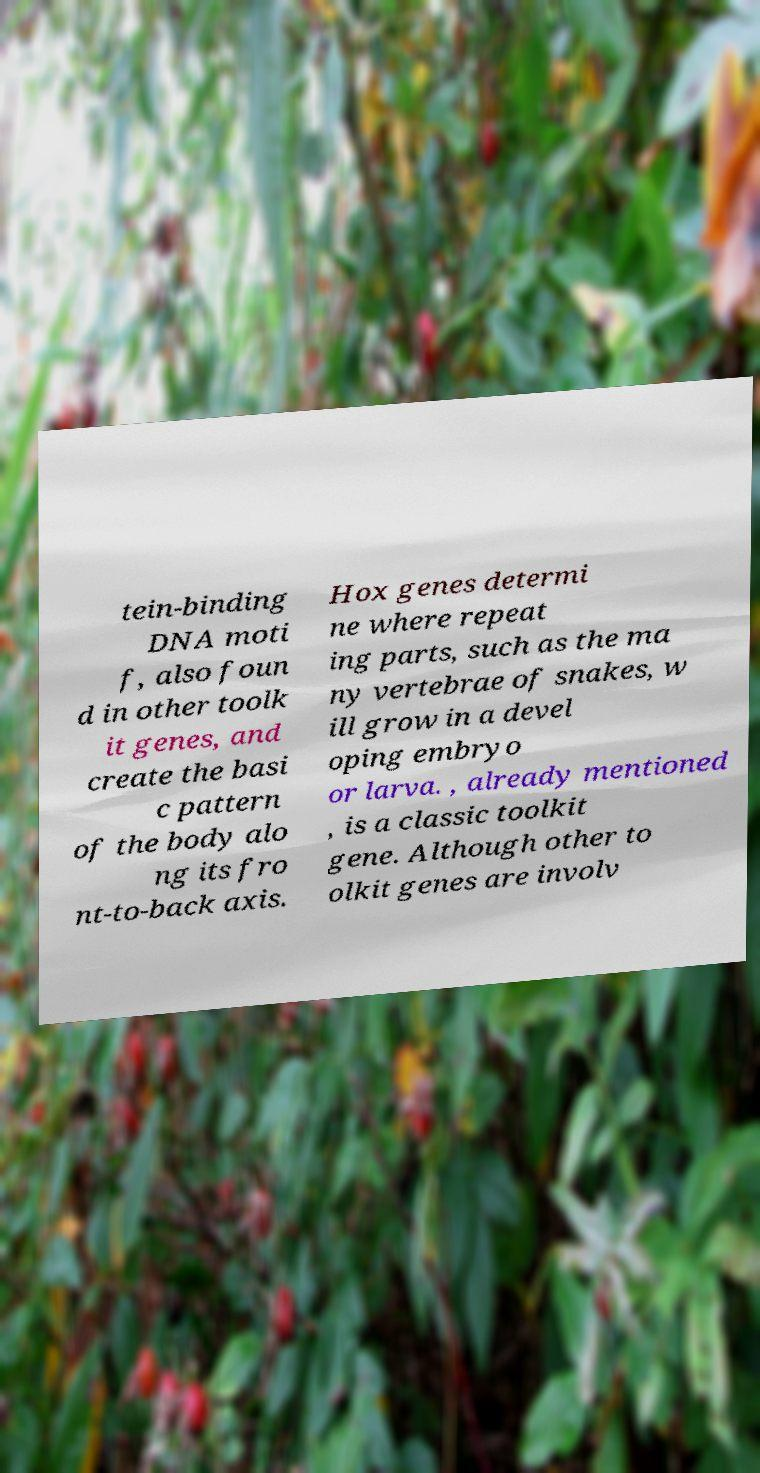There's text embedded in this image that I need extracted. Can you transcribe it verbatim? tein-binding DNA moti f, also foun d in other toolk it genes, and create the basi c pattern of the body alo ng its fro nt-to-back axis. Hox genes determi ne where repeat ing parts, such as the ma ny vertebrae of snakes, w ill grow in a devel oping embryo or larva. , already mentioned , is a classic toolkit gene. Although other to olkit genes are involv 